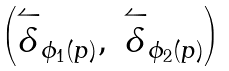Convert formula to latex. <formula><loc_0><loc_0><loc_500><loc_500>\begin{pmatrix} \overset { \leftharpoonup } { \delta } _ { \phi _ { 1 } ( p ) } , & \overset { \leftharpoonup } { \delta } _ { \phi _ { 2 } ( p ) } \end{pmatrix}</formula> 